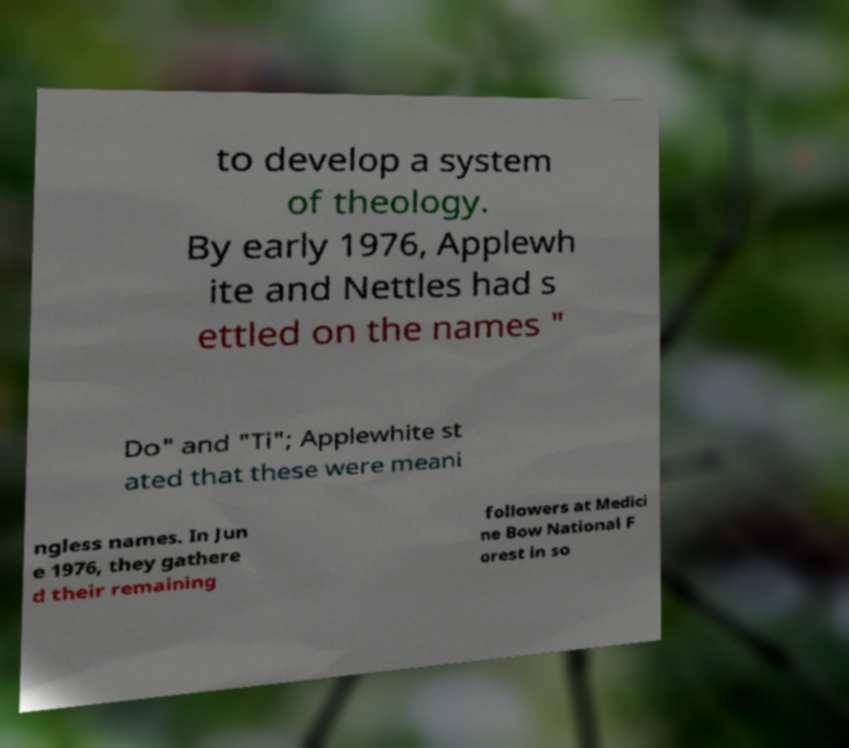For documentation purposes, I need the text within this image transcribed. Could you provide that? to develop a system of theology. By early 1976, Applewh ite and Nettles had s ettled on the names " Do" and "Ti"; Applewhite st ated that these were meani ngless names. In Jun e 1976, they gathere d their remaining followers at Medici ne Bow National F orest in so 